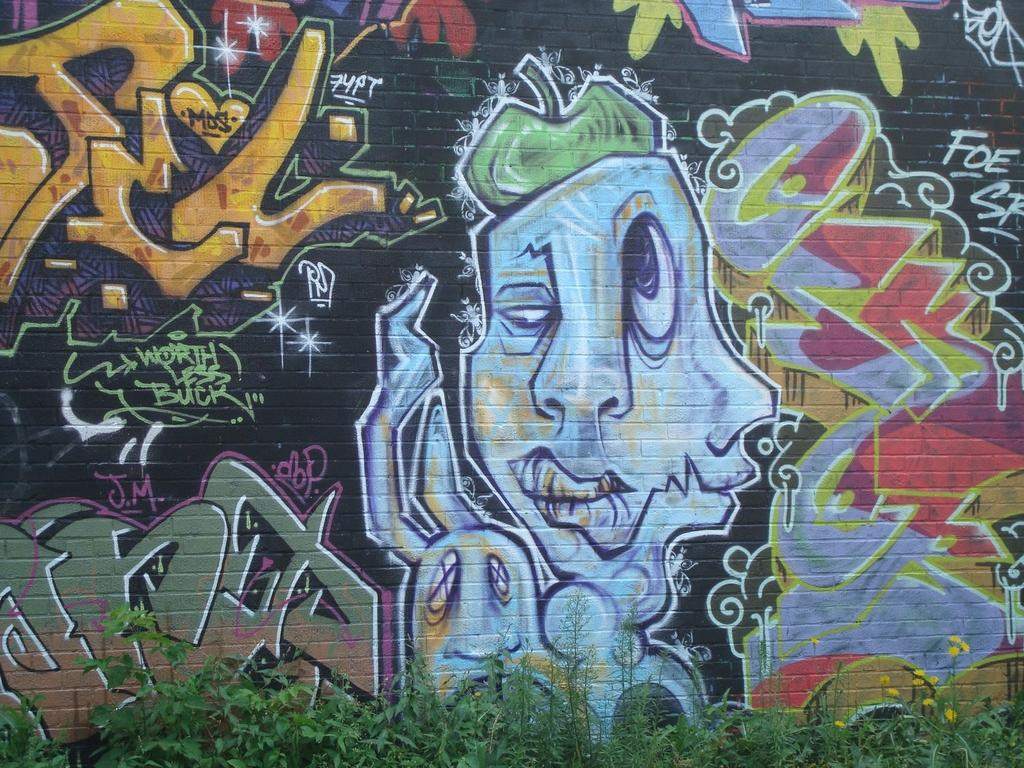What is present on the wall in the image? There is a painting on the wall in the image. What else can be seen at the bottom of the image? There are plants at the bottom of the image. Are there any flowers visible in the image? Yes, there are flowers in the image. What type of silk is being used to make the news in the image? There is no silk or news present in the image. How much sand can be seen in the image? There is no sand visible in the image. 